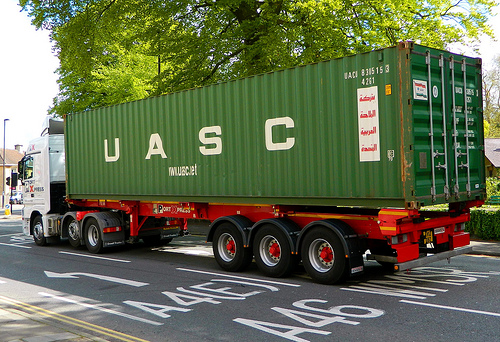On which side of the picture is the house? The house is situated on the right side of the picture. 